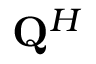Convert formula to latex. <formula><loc_0><loc_0><loc_500><loc_500>{ Q } ^ { H }</formula> 